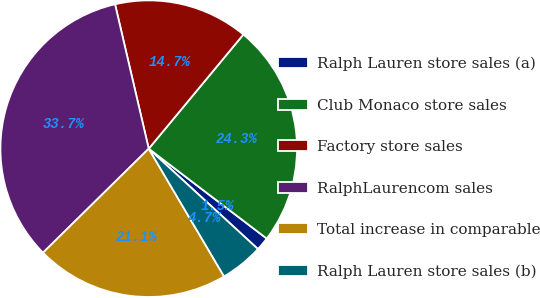<chart> <loc_0><loc_0><loc_500><loc_500><pie_chart><fcel>Ralph Lauren store sales (a)<fcel>Club Monaco store sales<fcel>Factory store sales<fcel>RalphLaurencom sales<fcel>Total increase in comparable<fcel>Ralph Lauren store sales (b)<nl><fcel>1.47%<fcel>24.34%<fcel>14.66%<fcel>33.72%<fcel>21.11%<fcel>4.69%<nl></chart> 